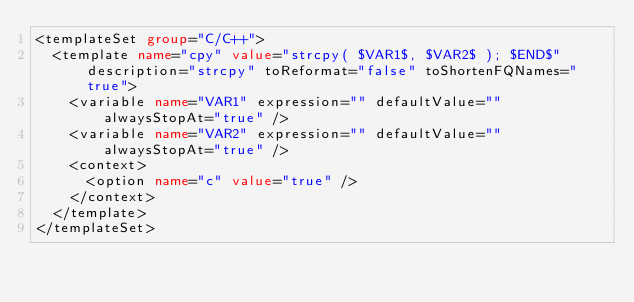Convert code to text. <code><loc_0><loc_0><loc_500><loc_500><_XML_><templateSet group="C/C++">
  <template name="cpy" value="strcpy( $VAR1$, $VAR2$ ); $END$" description="strcpy" toReformat="false" toShortenFQNames="true">
    <variable name="VAR1" expression="" defaultValue="" alwaysStopAt="true" />
    <variable name="VAR2" expression="" defaultValue="" alwaysStopAt="true" />
    <context>
      <option name="c" value="true" />
    </context>
  </template>
</templateSet></code> 